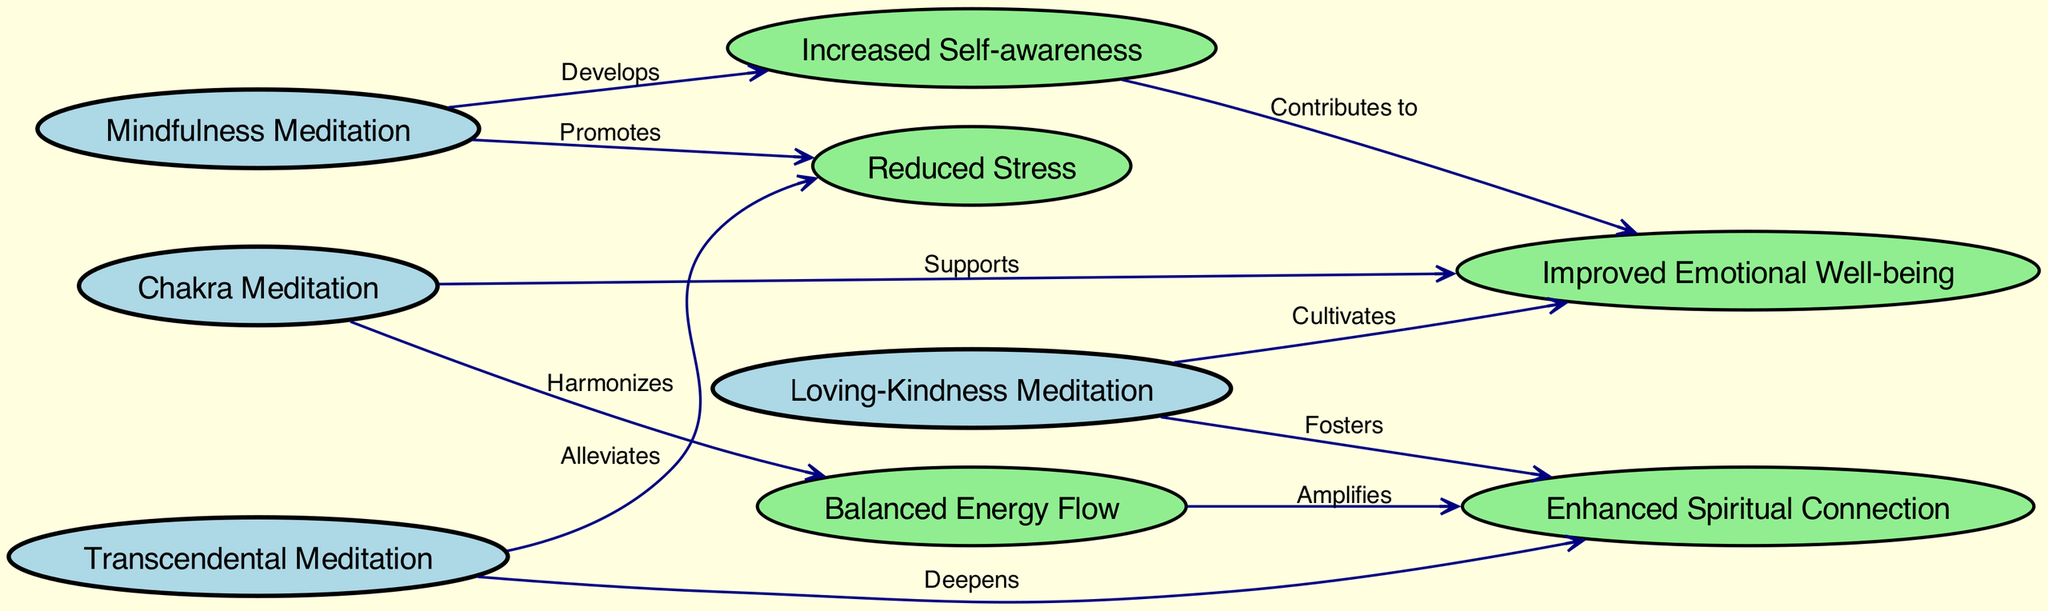What are the meditation practices shown in the diagram? The diagram lists four meditation practices: Mindfulness Meditation, Loving-Kindness Meditation, Transcendental Meditation, and Chakra Meditation. These practices are represented as nodes in the directed graph.
Answer: Mindfulness Meditation, Loving-Kindness Meditation, Transcendental Meditation, Chakra Meditation Which outcome is linked to Loving-Kindness Meditation? According to the diagram, Loving-Kindness Meditation cultivates Improved Emotional Well-being and fosters Enhanced Spiritual Connection. These outcomes are depicted as nodes that are connected to Loving-Kindness Meditation by directed edges.
Answer: Improved Emotional Well-being, Enhanced Spiritual Connection How many outcomes are derived from Mindfulness Meditation? In the graph, Mindfulness Meditation promotes Reduced Stress and develops Increased Self-awareness. Therefore, there are two outcomes directly linked to Mindfulness Meditation based on the directed edges shown.
Answer: 2 What is the relationship between Increased Self-awareness and Improved Emotional Well-being? The diagram indicates that Increased Self-awareness contributes to Improved Emotional Well-being. The directed edge from Increased Self-awareness to Improved Emotional Well-being confirms this connection and shows their interdependency.
Answer: Contributes to Which meditation practice is associated with Balanced Energy Flow? Chakra Meditation is the practice that harmonizes Balanced Energy Flow. This is illustrated in the directed graph as a connection from Chakra Meditation to Balanced Energy Flow.
Answer: Chakra Meditation How does Balanced Energy Flow affect Enhanced Spiritual Connection? The diagram illustrates that Balanced Energy Flow amplifies Enhanced Spiritual Connection through a directed edge. This means that when energy flow is balanced, it has a positive influence on one’s spiritual connectivity.
Answer: Amplifies What is the total number of nodes in the diagram? To find the total number of nodes, we can count all distinct items listed under "nodes" in the diagram. These include four meditation practices and five outcomes, totaling nine nodes.
Answer: 9 Which practice alleviates Reduced Stress? Transcendental Meditation is specified in the diagram as alleviating Reduced Stress, evidenced by the directed edge marking this relationship.
Answer: Transcendental Meditation What can we infer about the connection between Chakra Meditation and Improved Emotional Well-being? The diagram indicates that Chakra Meditation supports Improved Emotional Well-being. This is shown by the directed edge from Chakra Meditation to Improved Emotional Well-being, illustrating a supportive relationship.
Answer: Supports 